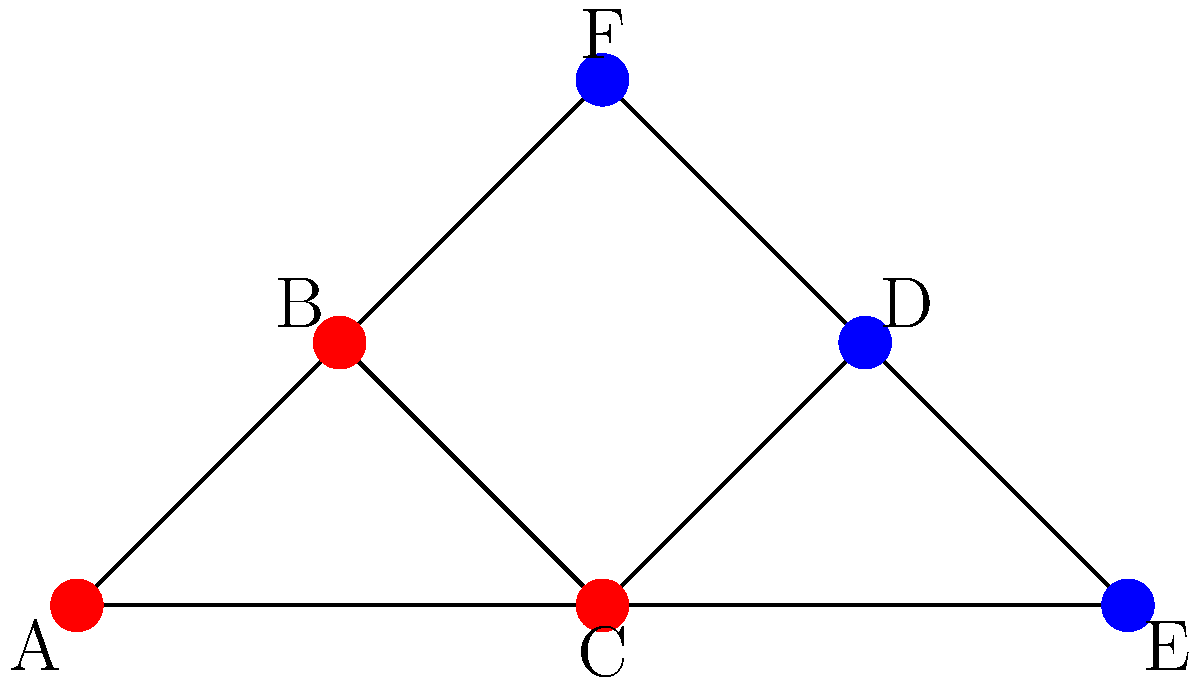In a network analysis of law firms and their client relationships, the graph above represents connections between different entities. Nodes A, B, and C represent law firms, while nodes D, E, and F represent clients. Using the Girvan-Newman algorithm for community detection, how many communities would be identified in this network? To determine the number of communities using the Girvan-Newman algorithm, we need to follow these steps:

1. Calculate edge betweenness centrality for all edges in the network.
2. Remove the edge with the highest betweenness centrality.
3. Recalculate betweenness centrality for all remaining edges.
4. Repeat steps 2 and 3 until the desired number of components is reached.

In this case:

1. The edge BC has the highest betweenness centrality as it connects two dense subgraphs.
2. Removing BC splits the graph into two components: {A, B, C} and {D, E, F}.
3. These two components cannot be further divided meaningfully, as removing any other edge would not create distinct communities.

The Girvan-Newman algorithm would stop here, identifying two distinct communities:
- Community 1: Law firms A, B, and C
- Community 2: Clients D, E, and F

This division reflects the natural grouping of law firms and clients in the network.
Answer: 2 communities 